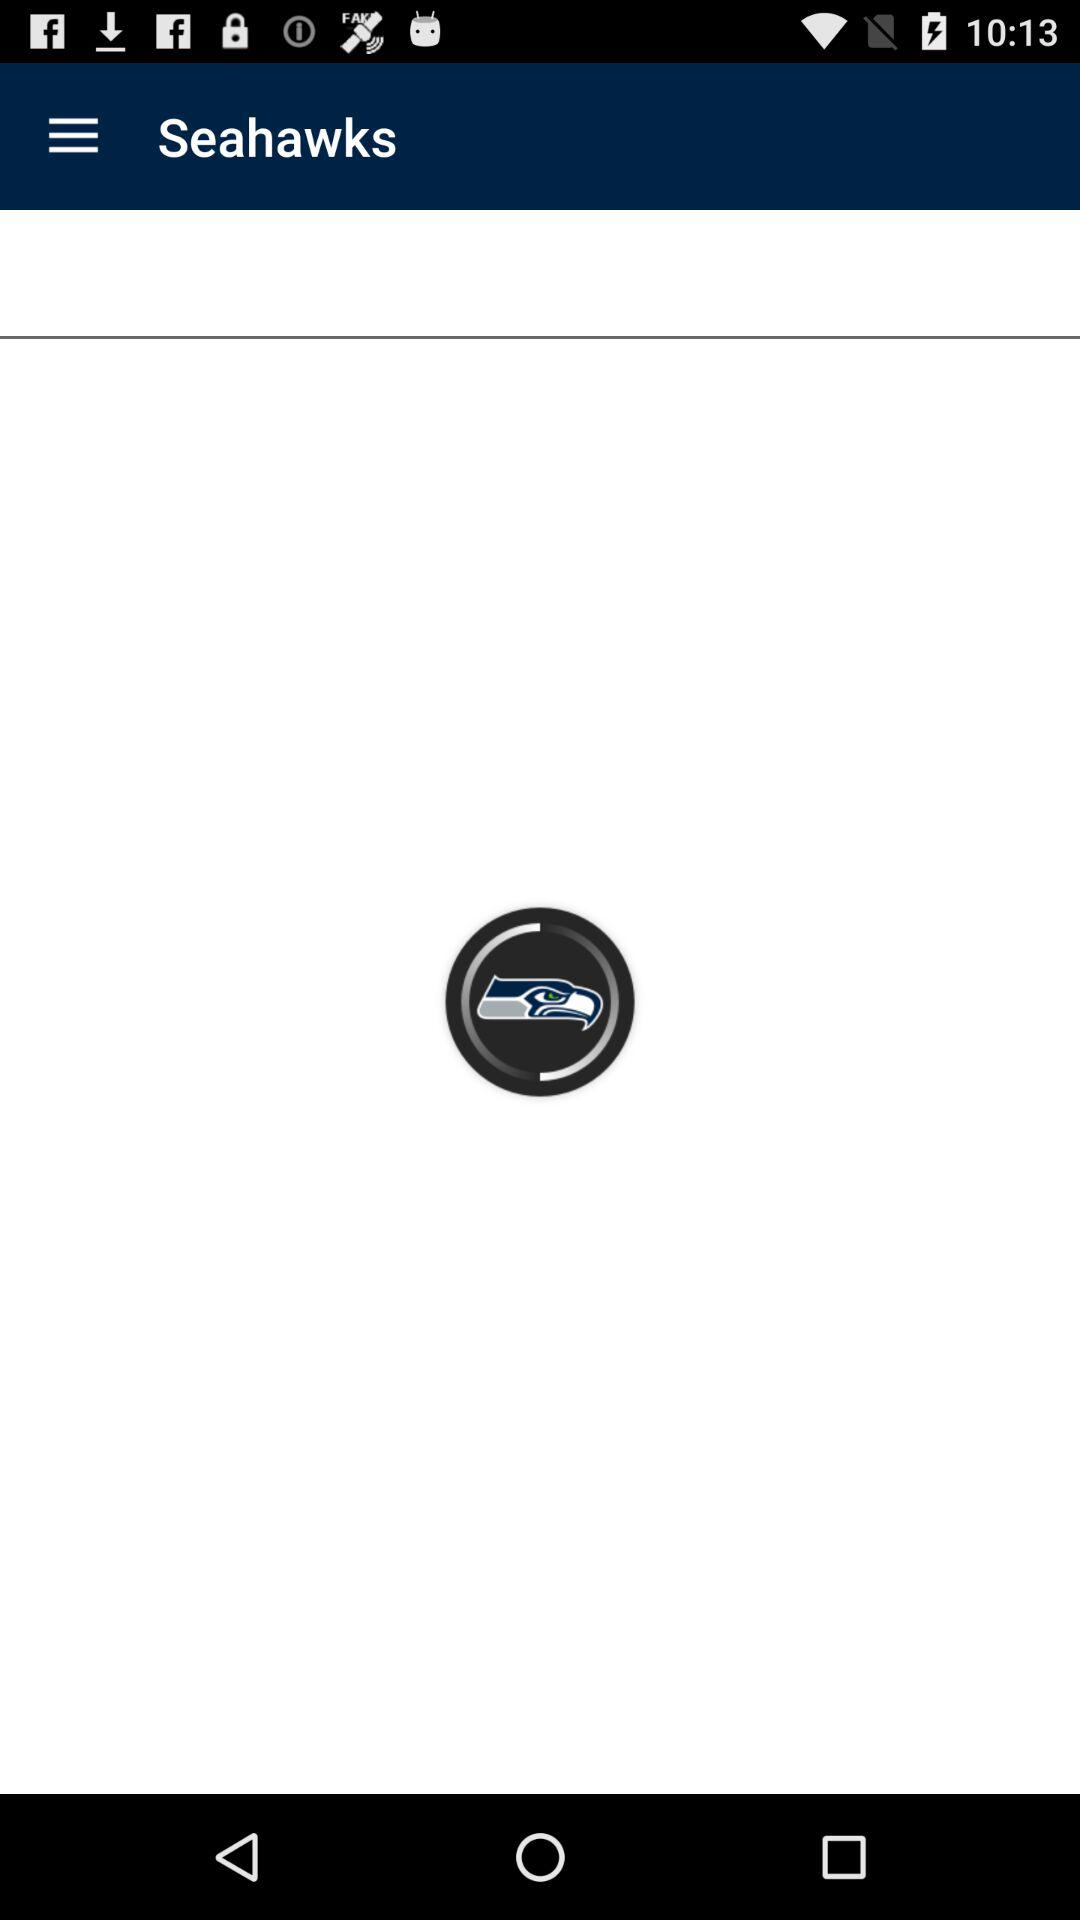What is the application name? The application name is "Seahawks". 